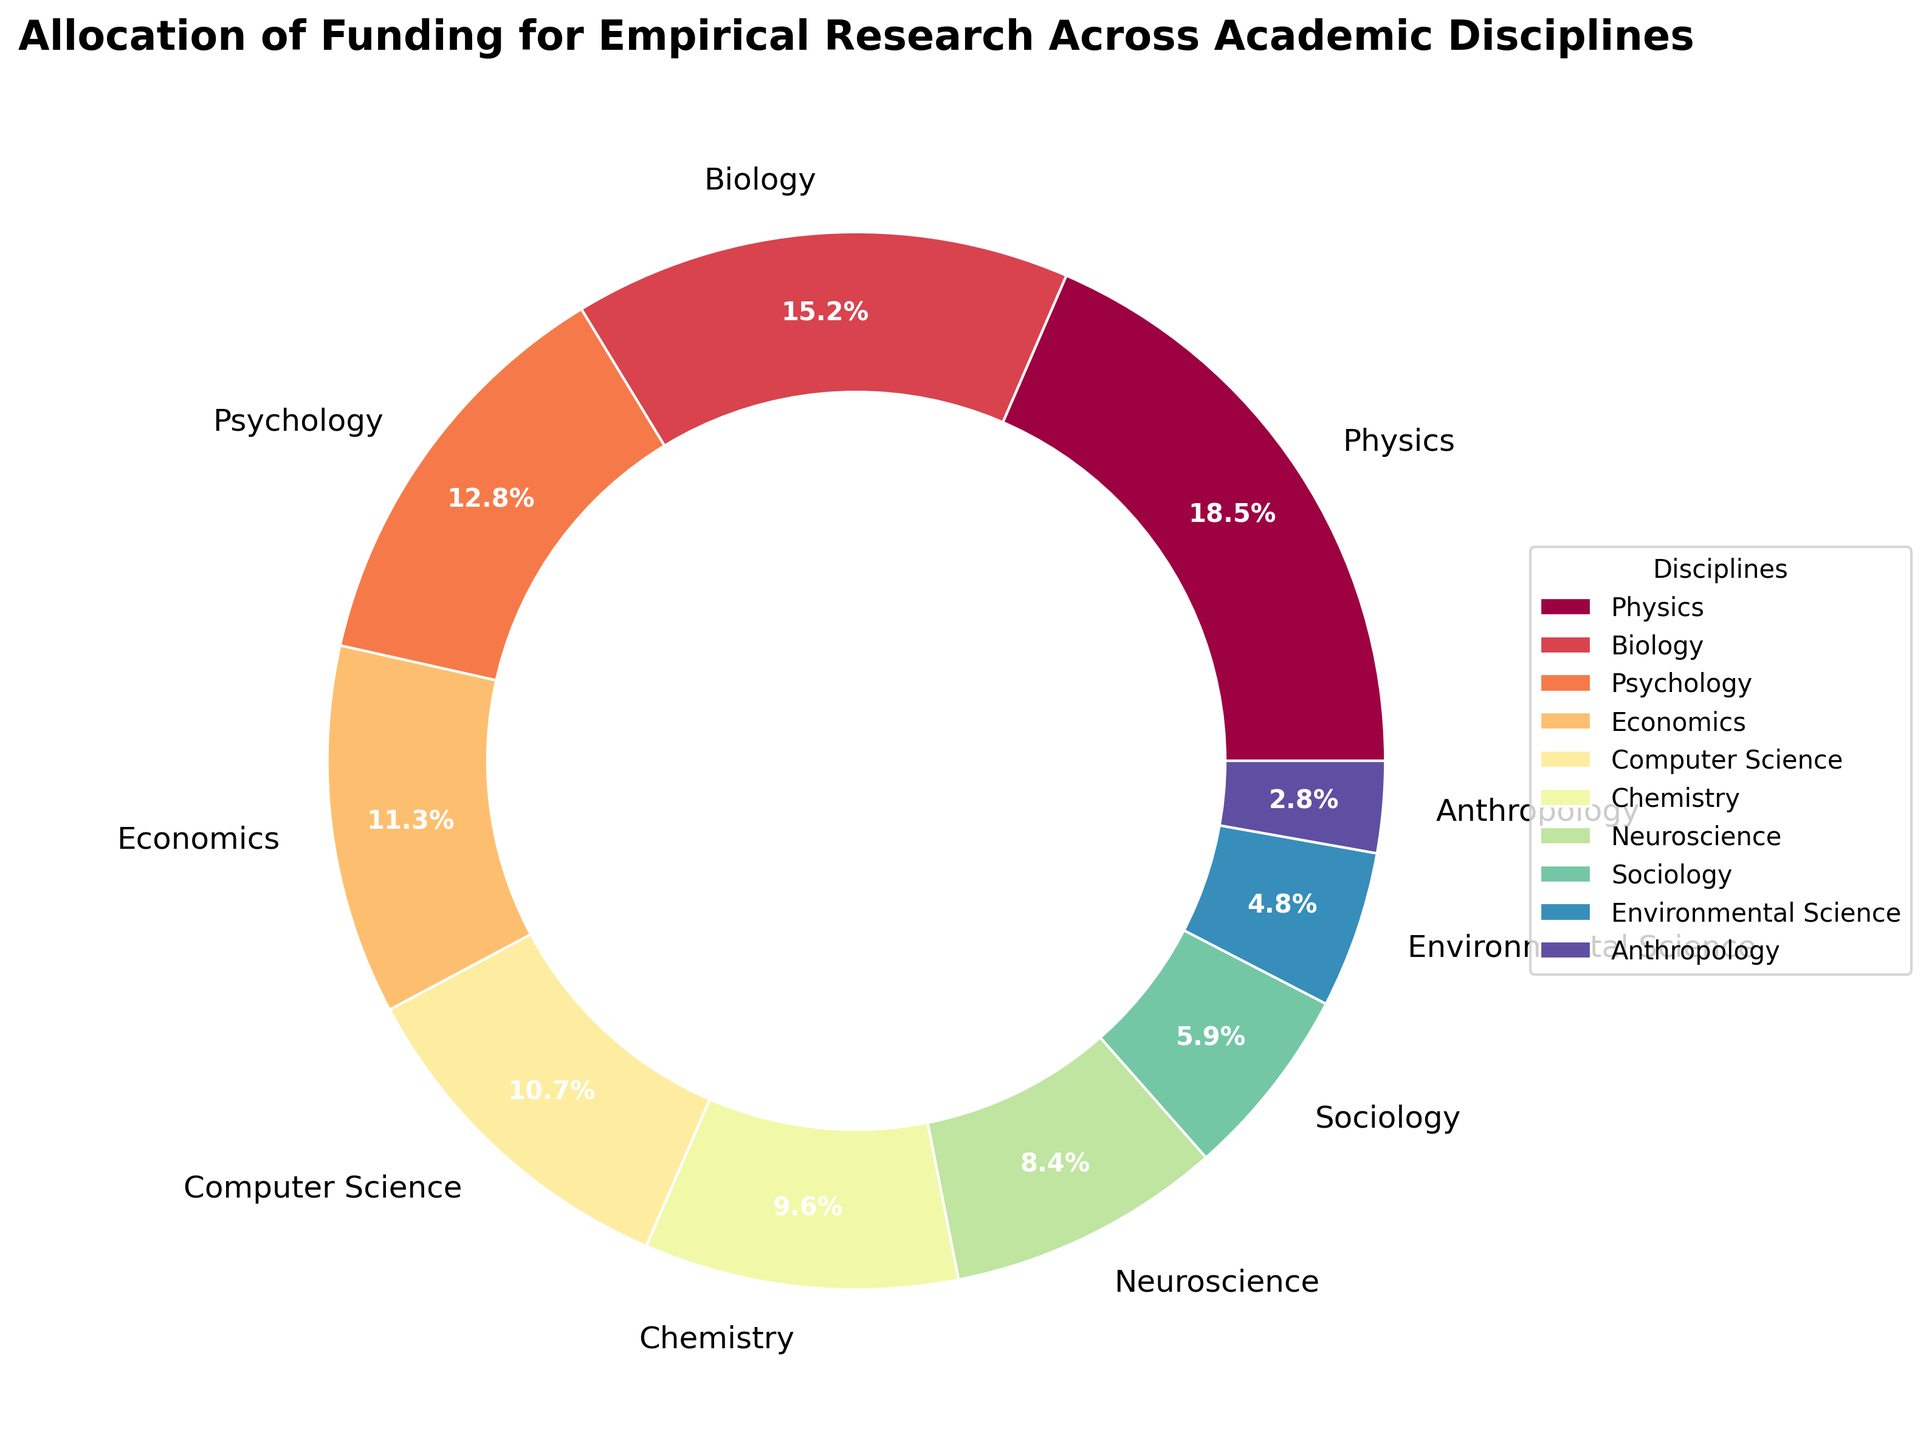Which discipline receives the highest percentage of funding? From the figure, the largest wedge of the pie chart is labeled Physics. Detailed observation also confirms that the percentage next to Physics is the highest.
Answer: Physics Which two disciplines together receive more funding than Psychology but less than Physics? Psychology receives 12.8%. Looking from lower to higher, Computer Science (10.7%) and Sociology (5.9%) together receive 16.6%, which is more than Psychology. Physics receives 18.5%, which is more than 16.6%.
Answer: Computer Science and Sociology What is the combined funding percentage for Biology and Chemistry? From the figure, Biology receives 15.2% and Chemistry receives 9.6%. Adding them together, 15.2% + 9.6% = 24.8%.
Answer: 24.8% Which discipline receives the least funding, and what is the percentage? The smallest wedge of the pie chart is labeled Anthropology. The percentage next to it is the smallest.
Answer: Anthropology at 2.8% How many disciplines receive more funding than Environmental Science? The percentage for Environmental Science is 4.8%. Observing all wedges with percentages greater than 4.8%, the disciplines are Physics, Biology, Psychology, Economics, Computer Science, Chemistry, Neuroscience, and Sociology, totaling 8 disciplines.
Answer: 8 Is the funding for Economics closer to that for Computer Science or Psychology? Economics receives 11.3%, Computer Science 10.7%, and Psychology 12.8%. The differences are 11.3 - 10.7 = 0.6 for Computer Science and 12.8 - 11.3 = 1.5 for Psychology, making it closer to Computer Science.
Answer: Computer Science What is the visual color used to represent Neuroscience? Looking at the pie chart, the wedge labeled Neuroscience corresponds to a specific color. The color directly matches what is used in the figure.
Answer: Check the specific visual representation in the figure By how much does the funding for Sociology differ from that for Anthropology? Sociology receives 5.9% and Anthropology receives 2.8%. The difference is 5.9% - 2.8% = 3.1%.
Answer: 3.1% What is the average funding percentage for the top three funded disciplines? The top three disciplines are Physics (18.5%), Biology (15.2%), and Psychology (12.8%). Adding and dividing by 3: (18.5 + 15.2 + 12.8) / 3 = 15.5%.
Answer: 15.5% 